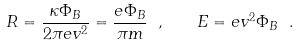Convert formula to latex. <formula><loc_0><loc_0><loc_500><loc_500>R = \frac { \kappa \Phi _ { B } } { 2 \pi e v ^ { 2 } } = \frac { e \Phi _ { B } } { \pi m } \ , \quad E = e v ^ { 2 } \Phi _ { B } \ .</formula> 